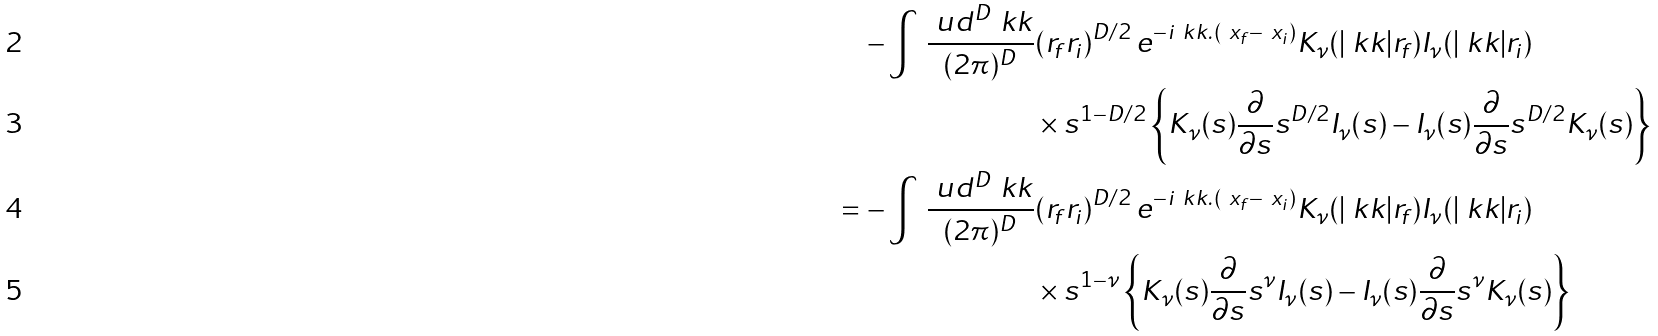Convert formula to latex. <formula><loc_0><loc_0><loc_500><loc_500>- \int \, \frac { \ u d ^ { D } \ k k } { ( 2 \pi ) ^ { D } } & ( r _ { f } r _ { i } ) ^ { D / 2 } \, e ^ { - i \ k k . ( \ x _ { f } - \ x _ { i } ) } K _ { \nu } ( | \ k k | r _ { f } ) I _ { \nu } ( | \ k k | r _ { i } ) \\ & \times s ^ { 1 - D / 2 } \left \{ K _ { \nu } ( s ) \frac { \partial } { \partial s } s ^ { D / 2 } I _ { \nu } ( s ) - I _ { \nu } ( s ) \frac { \partial } { \partial s } s ^ { D / 2 } K _ { \nu } ( s ) \right \} \\ = - \int \, \frac { \ u d ^ { D } \ k k } { ( 2 \pi ) ^ { D } } & ( r _ { f } r _ { i } ) ^ { D / 2 } \, e ^ { - i \ k k . ( \ x _ { f } - \ x _ { i } ) } K _ { \nu } ( | \ k k | r _ { f } ) I _ { \nu } ( | \ k k | r _ { i } ) \\ & \times s ^ { 1 - \nu } \left \{ K _ { \nu } ( s ) \frac { \partial } { \partial s } s ^ { \nu } I _ { \nu } ( s ) - I _ { \nu } ( s ) \frac { \partial } { \partial s } s ^ { \nu } K _ { \nu } ( s ) \right \}</formula> 